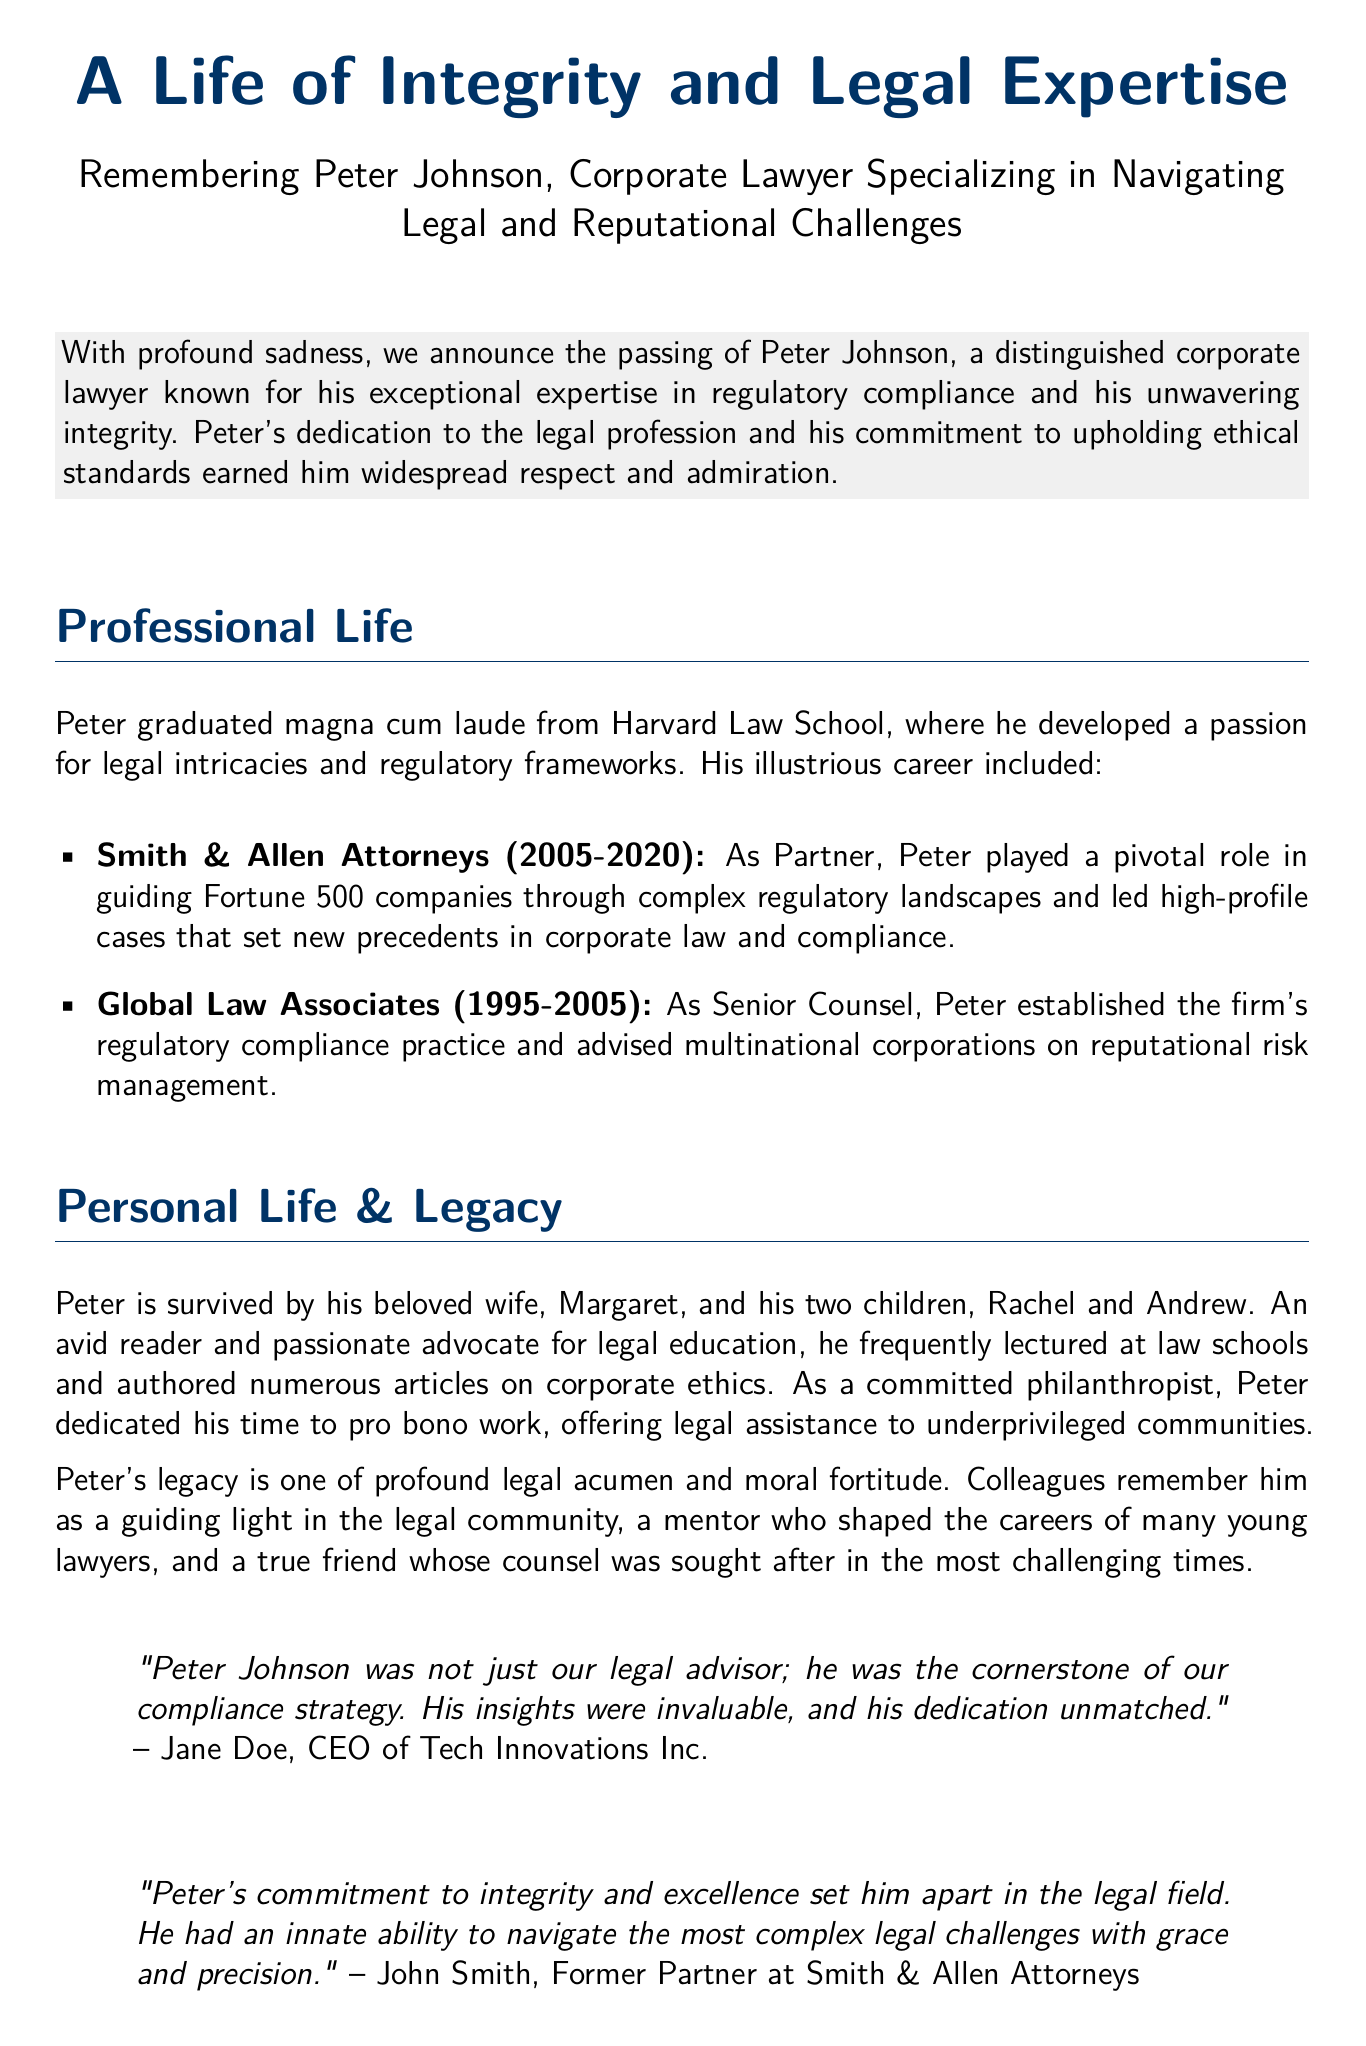What was Peter Johnson's profession? The document explicitly states that Peter Johnson was a corporate lawyer.
Answer: Corporate lawyer Where did Peter Johnson graduate from? The document states that Peter graduated magna cum laude from Harvard Law School.
Answer: Harvard Law School What years did Peter work at Smith & Allen Attorneys? The document provides the specific years Peter worked at Smith & Allen Attorneys from 2005 to 2020.
Answer: 2005-2020 Who is Peter Johnson survived by? The document mentions that he is survived by his wife, Margaret, and two children, Rachel and Andrew.
Answer: Margaret, Rachel, Andrew What was one of Peter's key roles at Global Law Associates? The document indicates that he established the firm's regulatory compliance practice.
Answer: Established regulatory compliance practice How is Peter Johnson described by Jane Doe? The document includes a quote describing Peter as the cornerstone of their compliance strategy.
Answer: Cornerstone of our compliance strategy What notable trait did Peter have according to John Smith? The document expresses that Peter had an innate ability to navigate complex legal challenges.
Answer: Innate ability to navigate complex legal challenges What type of work did Peter Johnson dedicate time to aside from his legal career? The document mentions that he dedicated time to pro bono work for underprivileged communities.
Answer: Pro bono work In what area did Peter frequently lecture? The document specifies that he frequently lectured at law schools.
Answer: Law schools 